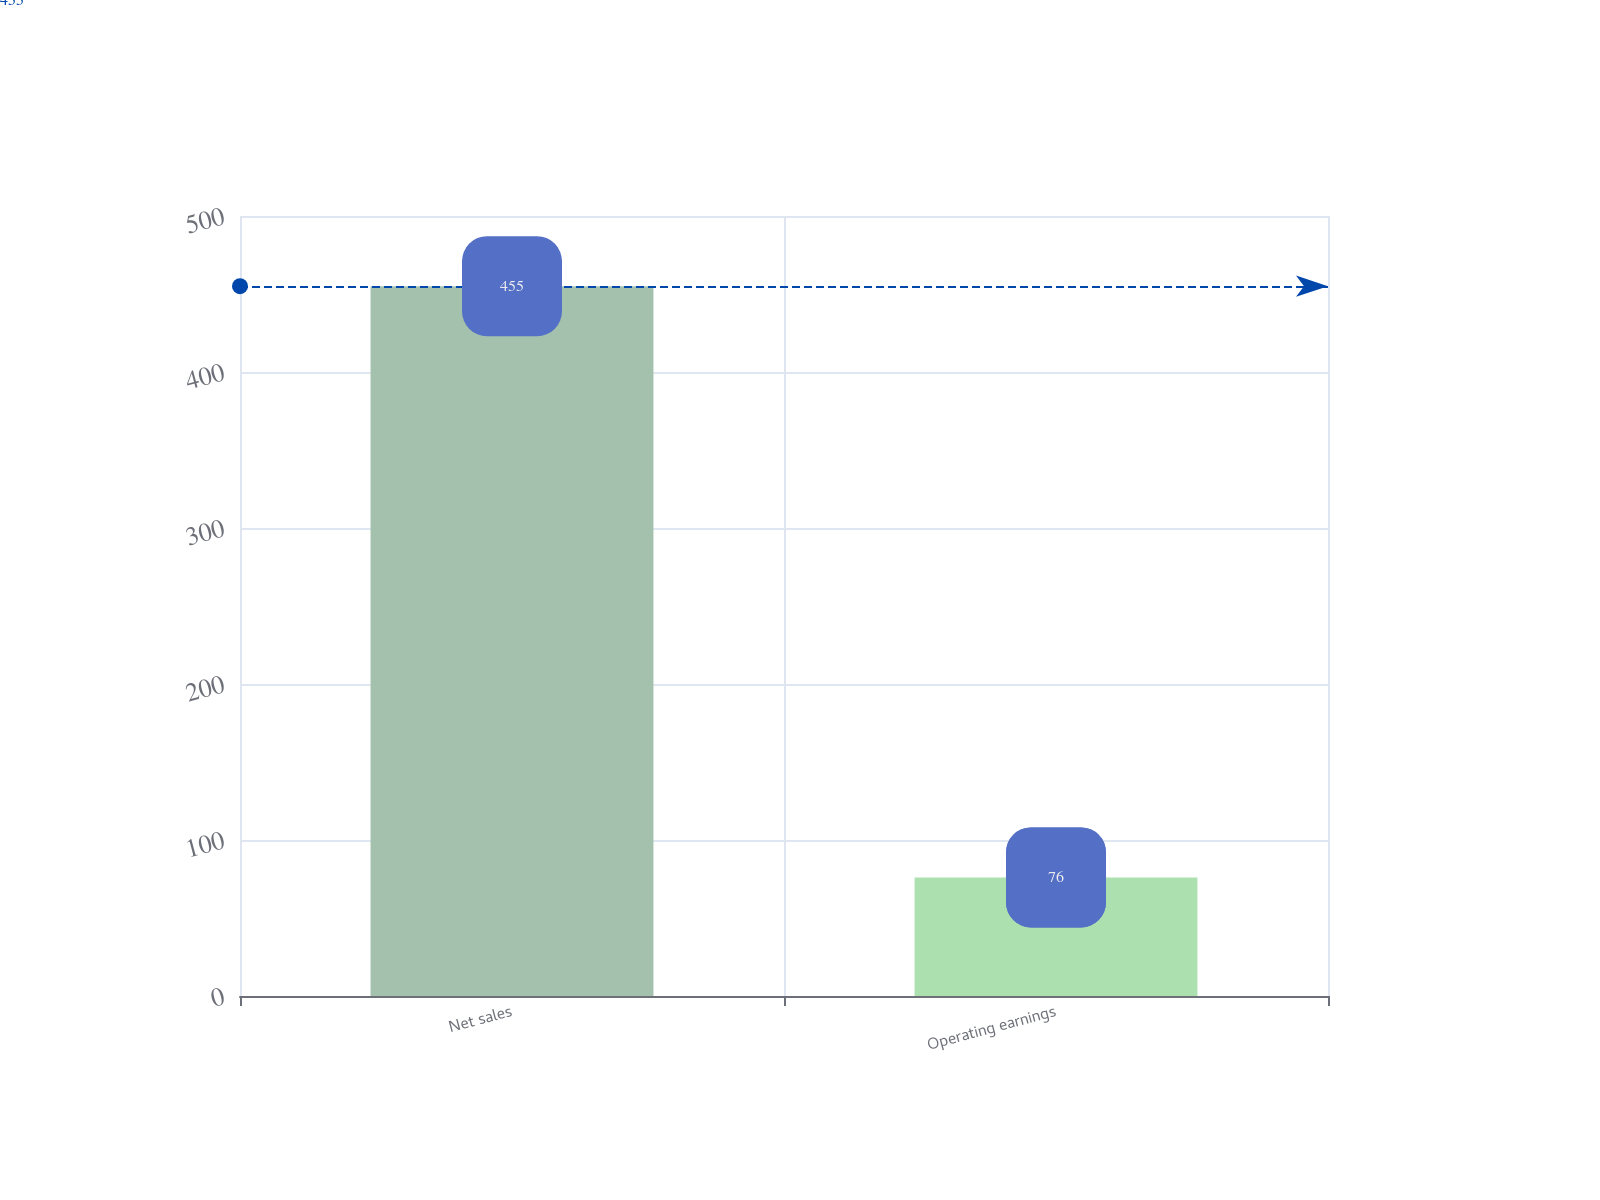<chart> <loc_0><loc_0><loc_500><loc_500><bar_chart><fcel>Net sales<fcel>Operating earnings<nl><fcel>455<fcel>76<nl></chart> 